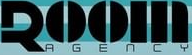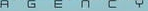What words can you see in these images in sequence, separated by a semicolon? ROOM; AGENCY 